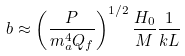Convert formula to latex. <formula><loc_0><loc_0><loc_500><loc_500>b \approx \left ( \frac { P } { m _ { a } ^ { 4 } Q _ { f } } \right ) ^ { 1 / 2 } \frac { H _ { 0 } } { M } \frac { 1 } { k L }</formula> 